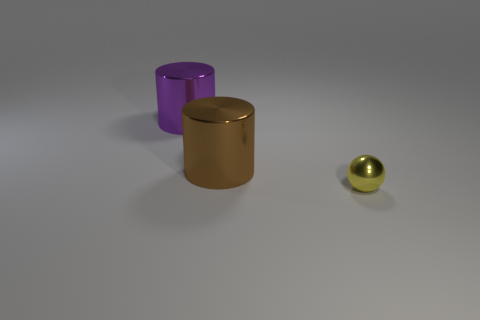Are any big purple metallic cylinders visible?
Provide a succinct answer. Yes. What is the shape of the small metal thing in front of the cylinder that is behind the large brown metallic thing?
Offer a terse response. Sphere. What number of objects are either metal things that are left of the small thing or things to the left of the ball?
Provide a succinct answer. 2. There is a brown cylinder that is the same size as the purple cylinder; what is its material?
Offer a terse response. Metal. There is a thing that is both behind the small yellow shiny object and right of the big purple thing; what material is it?
Your response must be concise. Metal. Is there a thing in front of the big thing on the left side of the big cylinder that is on the right side of the purple thing?
Give a very brief answer. Yes. Are there any things behind the large brown cylinder?
Provide a short and direct response. Yes. How many other things are the same shape as the large brown object?
Ensure brevity in your answer.  1. What color is the cylinder that is the same size as the purple object?
Offer a very short reply. Brown. Are there fewer purple shiny cylinders behind the brown metal cylinder than small yellow things to the right of the small yellow object?
Give a very brief answer. No. 